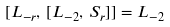<formula> <loc_0><loc_0><loc_500><loc_500>[ L _ { - r } , \, [ L _ { - 2 } , \, S _ { r } ] ] = L _ { - 2 }</formula> 